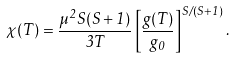<formula> <loc_0><loc_0><loc_500><loc_500>\chi ( T ) = \frac { \mu ^ { 2 } S ( S + 1 ) } { 3 T } \left [ \frac { g ( T ) } { g _ { 0 } } \right ] ^ { S / ( S + 1 ) } .</formula> 